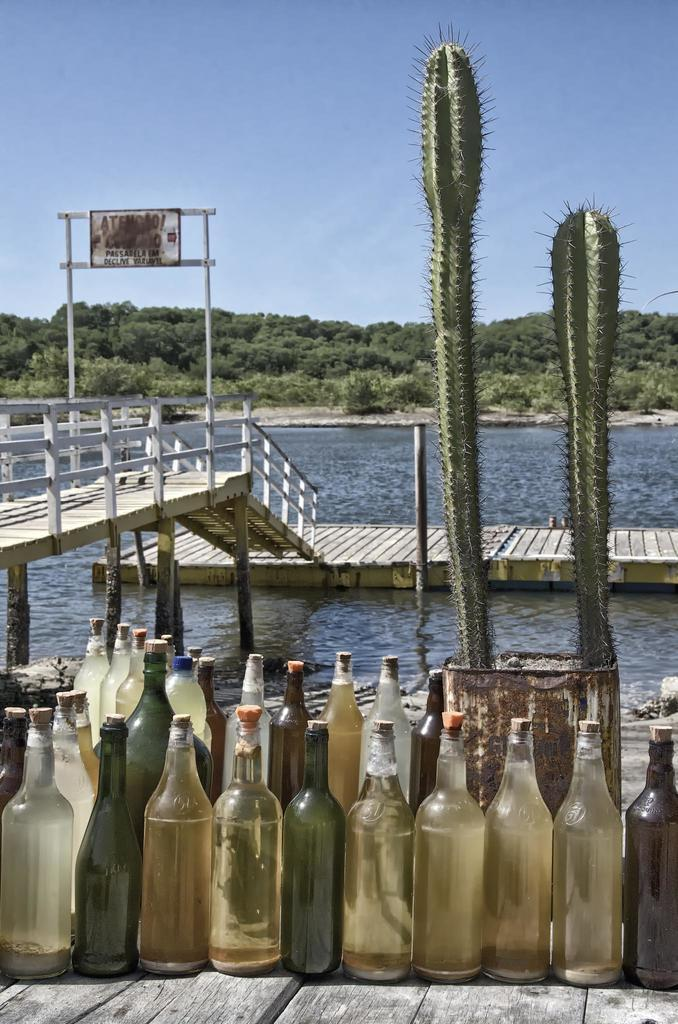What objects are on the ground in the image? There is a group of bottles on the ground in the image. What type of plant is located behind the bottles? There is a cactus plant behind the bottles. What can be seen in the background of the image? In the background, there is a bridge, water, a group of trees, and a blue sky. What structure is visible in the background? There is a board in the background. How many fans are visible in the image? There are no fans present in the image. What type of attention is the cactus plant receiving in the image? The cactus plant is not receiving any specific attention in the image; it is simply located behind the group of bottles. 